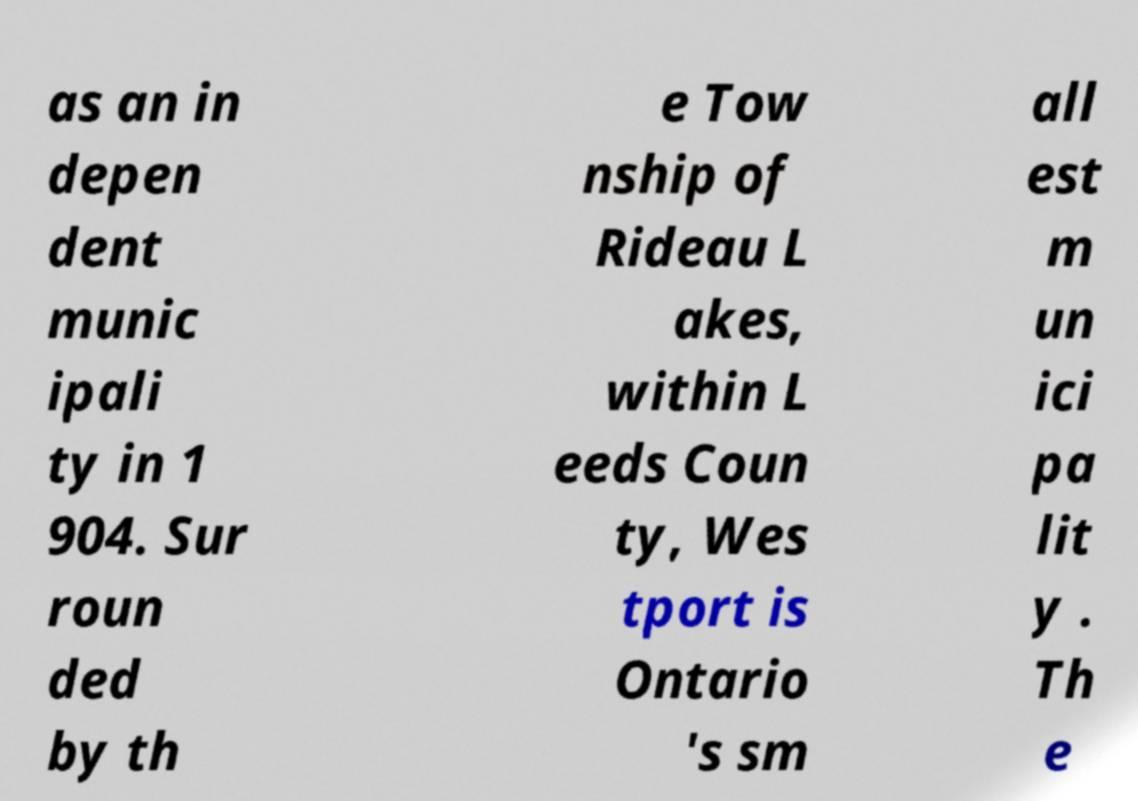For documentation purposes, I need the text within this image transcribed. Could you provide that? as an in depen dent munic ipali ty in 1 904. Sur roun ded by th e Tow nship of Rideau L akes, within L eeds Coun ty, Wes tport is Ontario 's sm all est m un ici pa lit y . Th e 